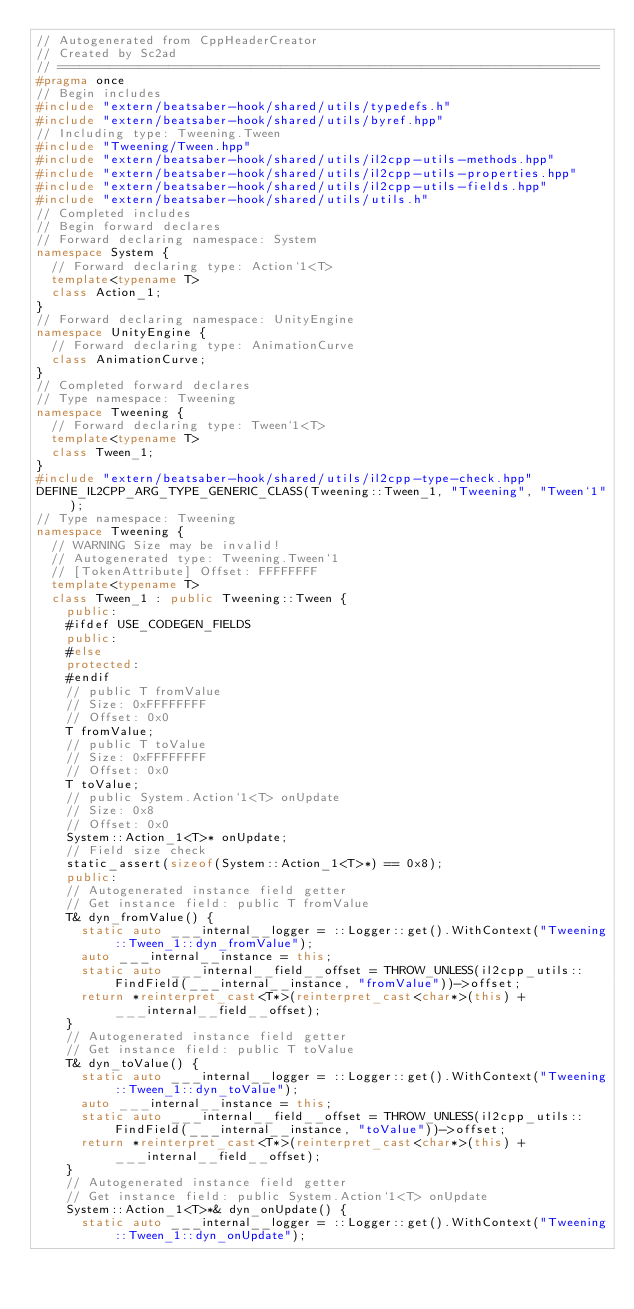<code> <loc_0><loc_0><loc_500><loc_500><_C++_>// Autogenerated from CppHeaderCreator
// Created by Sc2ad
// =========================================================================
#pragma once
// Begin includes
#include "extern/beatsaber-hook/shared/utils/typedefs.h"
#include "extern/beatsaber-hook/shared/utils/byref.hpp"
// Including type: Tweening.Tween
#include "Tweening/Tween.hpp"
#include "extern/beatsaber-hook/shared/utils/il2cpp-utils-methods.hpp"
#include "extern/beatsaber-hook/shared/utils/il2cpp-utils-properties.hpp"
#include "extern/beatsaber-hook/shared/utils/il2cpp-utils-fields.hpp"
#include "extern/beatsaber-hook/shared/utils/utils.h"
// Completed includes
// Begin forward declares
// Forward declaring namespace: System
namespace System {
  // Forward declaring type: Action`1<T>
  template<typename T>
  class Action_1;
}
// Forward declaring namespace: UnityEngine
namespace UnityEngine {
  // Forward declaring type: AnimationCurve
  class AnimationCurve;
}
// Completed forward declares
// Type namespace: Tweening
namespace Tweening {
  // Forward declaring type: Tween`1<T>
  template<typename T>
  class Tween_1;
}
#include "extern/beatsaber-hook/shared/utils/il2cpp-type-check.hpp"
DEFINE_IL2CPP_ARG_TYPE_GENERIC_CLASS(Tweening::Tween_1, "Tweening", "Tween`1");
// Type namespace: Tweening
namespace Tweening {
  // WARNING Size may be invalid!
  // Autogenerated type: Tweening.Tween`1
  // [TokenAttribute] Offset: FFFFFFFF
  template<typename T>
  class Tween_1 : public Tweening::Tween {
    public:
    #ifdef USE_CODEGEN_FIELDS
    public:
    #else
    protected:
    #endif
    // public T fromValue
    // Size: 0xFFFFFFFF
    // Offset: 0x0
    T fromValue;
    // public T toValue
    // Size: 0xFFFFFFFF
    // Offset: 0x0
    T toValue;
    // public System.Action`1<T> onUpdate
    // Size: 0x8
    // Offset: 0x0
    System::Action_1<T>* onUpdate;
    // Field size check
    static_assert(sizeof(System::Action_1<T>*) == 0x8);
    public:
    // Autogenerated instance field getter
    // Get instance field: public T fromValue
    T& dyn_fromValue() {
      static auto ___internal__logger = ::Logger::get().WithContext("Tweening::Tween_1::dyn_fromValue");
      auto ___internal__instance = this;
      static auto ___internal__field__offset = THROW_UNLESS(il2cpp_utils::FindField(___internal__instance, "fromValue"))->offset;
      return *reinterpret_cast<T*>(reinterpret_cast<char*>(this) + ___internal__field__offset);
    }
    // Autogenerated instance field getter
    // Get instance field: public T toValue
    T& dyn_toValue() {
      static auto ___internal__logger = ::Logger::get().WithContext("Tweening::Tween_1::dyn_toValue");
      auto ___internal__instance = this;
      static auto ___internal__field__offset = THROW_UNLESS(il2cpp_utils::FindField(___internal__instance, "toValue"))->offset;
      return *reinterpret_cast<T*>(reinterpret_cast<char*>(this) + ___internal__field__offset);
    }
    // Autogenerated instance field getter
    // Get instance field: public System.Action`1<T> onUpdate
    System::Action_1<T>*& dyn_onUpdate() {
      static auto ___internal__logger = ::Logger::get().WithContext("Tweening::Tween_1::dyn_onUpdate");</code> 